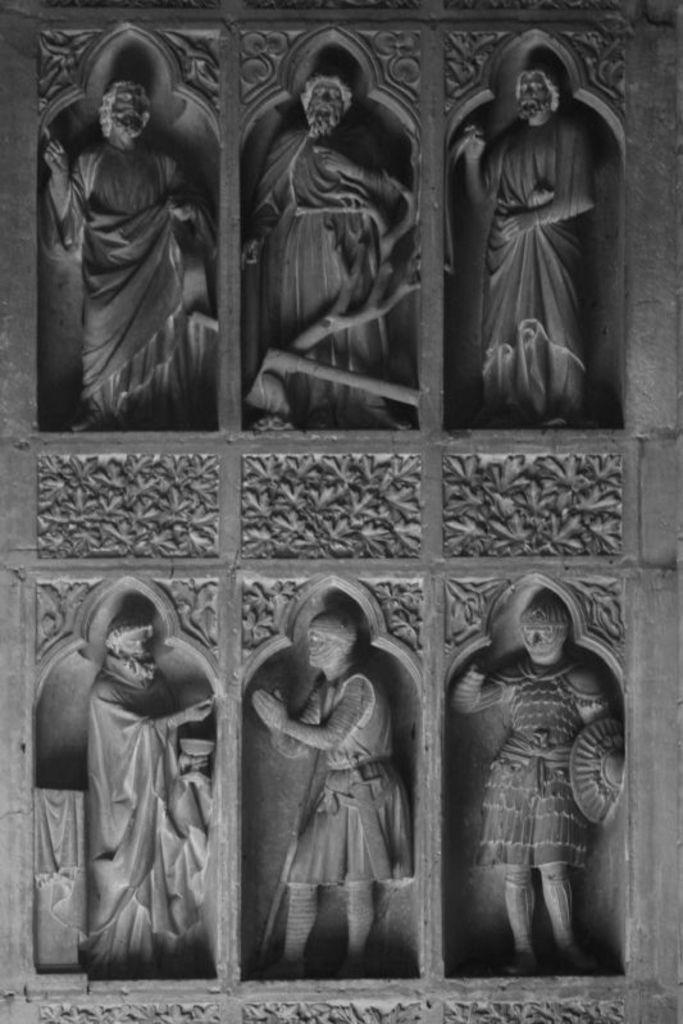Please provide a concise description of this image. In this image it might be the wall , on the wall I can see six sculptures and a design. 